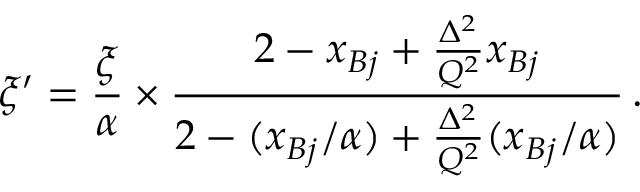<formula> <loc_0><loc_0><loc_500><loc_500>\xi ^ { \prime } = \frac { \xi } { \alpha } \times \frac { 2 - x _ { B j } + \frac { \Delta ^ { 2 } } { Q ^ { 2 } } x _ { B j } } { 2 - ( x _ { B j } / \alpha ) + \frac { \Delta ^ { 2 } } { Q ^ { 2 } } ( x _ { B j } / \alpha ) } \, .</formula> 